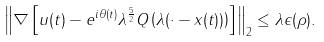<formula> <loc_0><loc_0><loc_500><loc_500>\left \| \nabla \left [ u ( t ) - e ^ { i \theta ( t ) } \lambda ^ { \frac { 5 } { 2 } } Q \left ( \lambda ( \cdot - x ( t ) ) \right ) \right ] \right \| _ { 2 } \leq \lambda \epsilon ( \rho ) .</formula> 